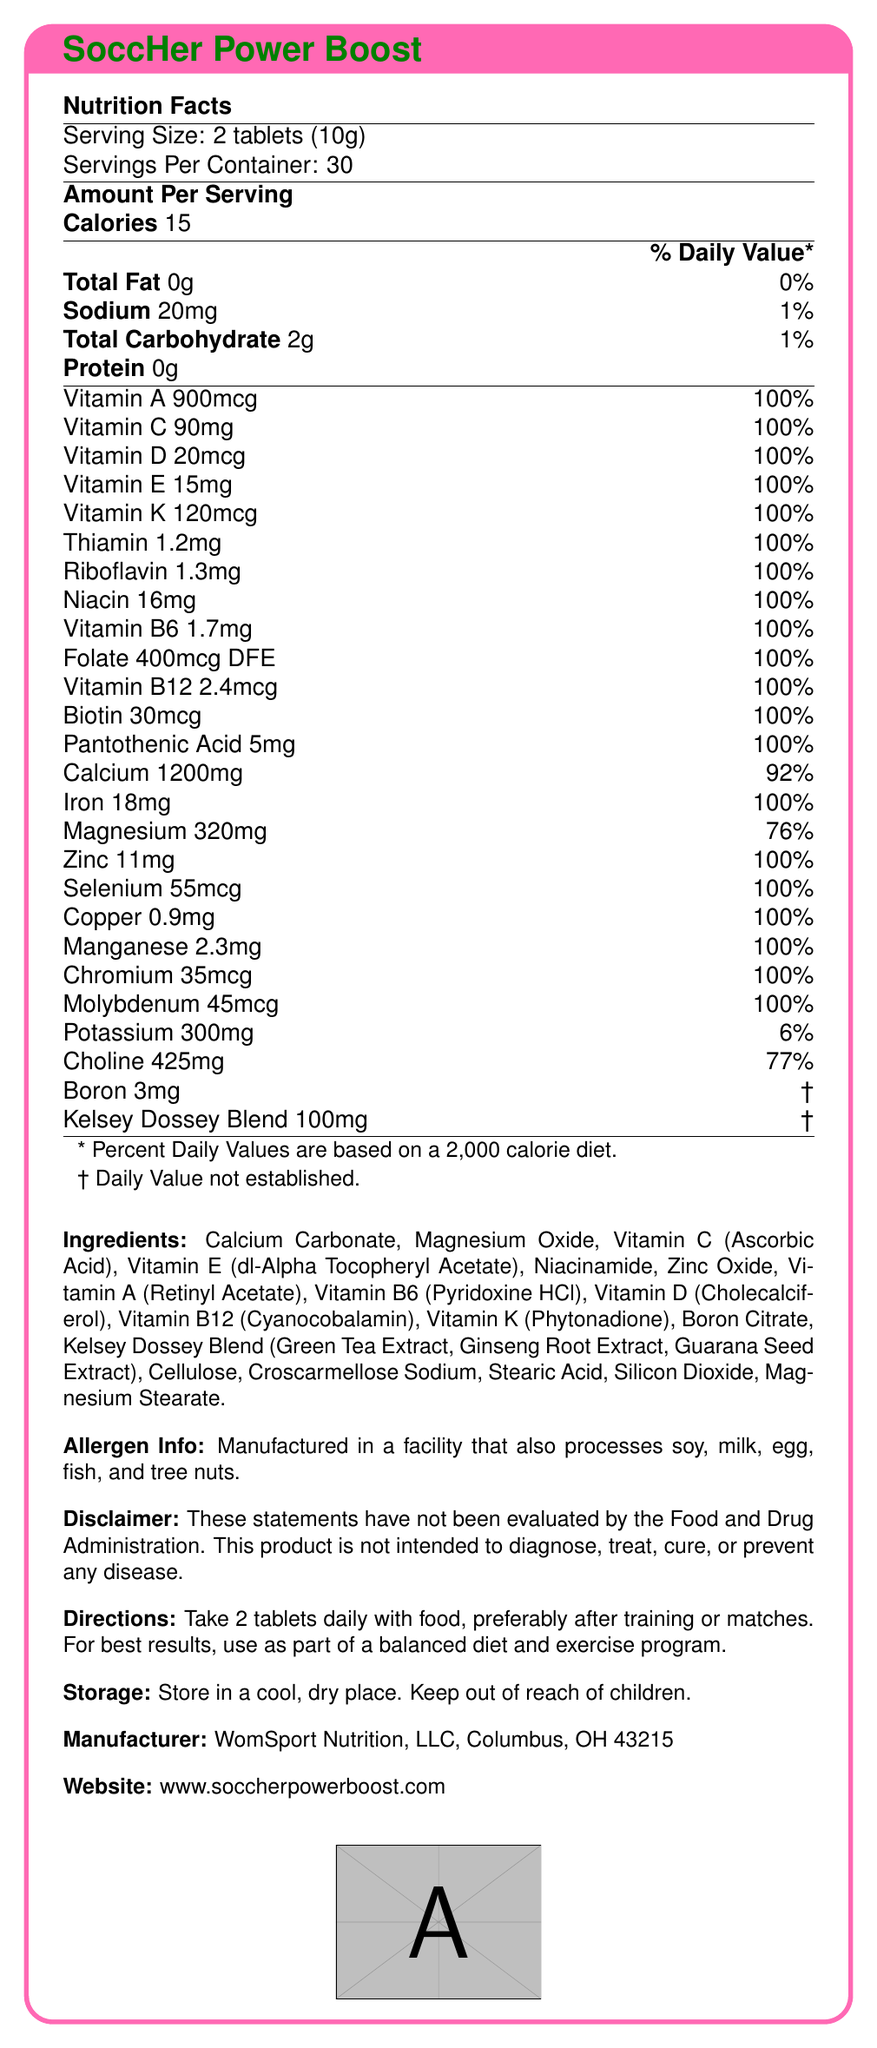What is the serving size for SoccHer Power Boost? The serving size is clearly listed as 2 tablets (10g) on the Nutrition Facts Label.
Answer: 2 tablets (10g) How many calories are in a serving of SoccHer Power Boost? The Nutrition Facts Label lists the number of calories per serving as 15.
Answer: 15 calories Which vitamins are included at 100% of the daily value per serving? The label indicates that several vitamins and minerals are provided at 100% of their daily value per serving.
Answer: Vitamin A, Vitamin C, Vitamin D, Vitamin E, Vitamin K, Thiamin, Riboflavin, Niacin, Vitamin B6, Folate, Vitamin B12, Biotin, Pantothenic Acid, Iron, Zinc, Selenium, Copper, Manganese, Chromium, Molybdenum What is the amount of calcium per serving, and how does it compare to the daily value? The label shows that there are 1200mg of calcium per serving, which is 92% of the daily value.
Answer: 1200mg, 92% Are there any allergens listed for SoccHer Power Boost? The label mentions that the product is manufactured in a facility that processes soy, milk, egg, fish, and tree nuts.
Answer: Yes What is the 'Kelsey Dossey Blend' and how much of it is included per serving? The 'Kelsey Dossey Blend' consists of Green Tea Extract, Ginseng Root Extract, and Guarana Seed Extract, and is listed as 100mg per serving.
Answer: 100mg What is the recommended usage direction for SoccHer Power Boost? A. Take 1 tablet daily B. Take 2 tablets daily with food C. Take 3 tablets before a match The directions state to take 2 tablets daily with food.
Answer: B. Take 2 tablets daily with food What does the disclaimer at the bottom of the label state? A. These statements are FDA approved B. These statements can cure diseases C. These statements have not been evaluated by the FDA The disclaimer explicitly mentions that the statements have not been evaluated by the FDA.
Answer: C. These statements have not been evaluated by the FDA Is SoccHer Power Boost suitable for vegetarians? The document does not provide any information regarding the suitability of the tablet for vegetarians.
Answer: Cannot be determined Does the product contain any protein? The Nutrition Facts Label clearly states that there is 0g of protein per serving.
Answer: No True or False: The product is manufactured by WomSport Nutrition, LLC, located in Columbus, OH. The manufacturer's information states WomSport Nutrition, LLC, Columbus, OH 43215.
Answer: True Summarize the entire document. The document thoroughly describes the supplement, its nutritional content, instructions for use, allergen information, manufacturing details, and includes an FDA disclaimer.
Answer: SoccHer Power Boost is a vitamin supplement tailored for women's nutritional needs in high-intensity sports like soccer. The nutritional facts per serving (2 tablets, 10g) include 15 calories and a variety of vitamins and minerals, many of which are at 100% of the daily value. The Kelsey Dossey Blend includes extracts such as Green Tea, Ginseng Root, and Guarana Seed, and the product is produced in a facility that handles common allergens. Usage instructions recommend taking 2 tablets daily with food. The product also includes a disclaimer that it is not FDA evaluated for treating diseases. 